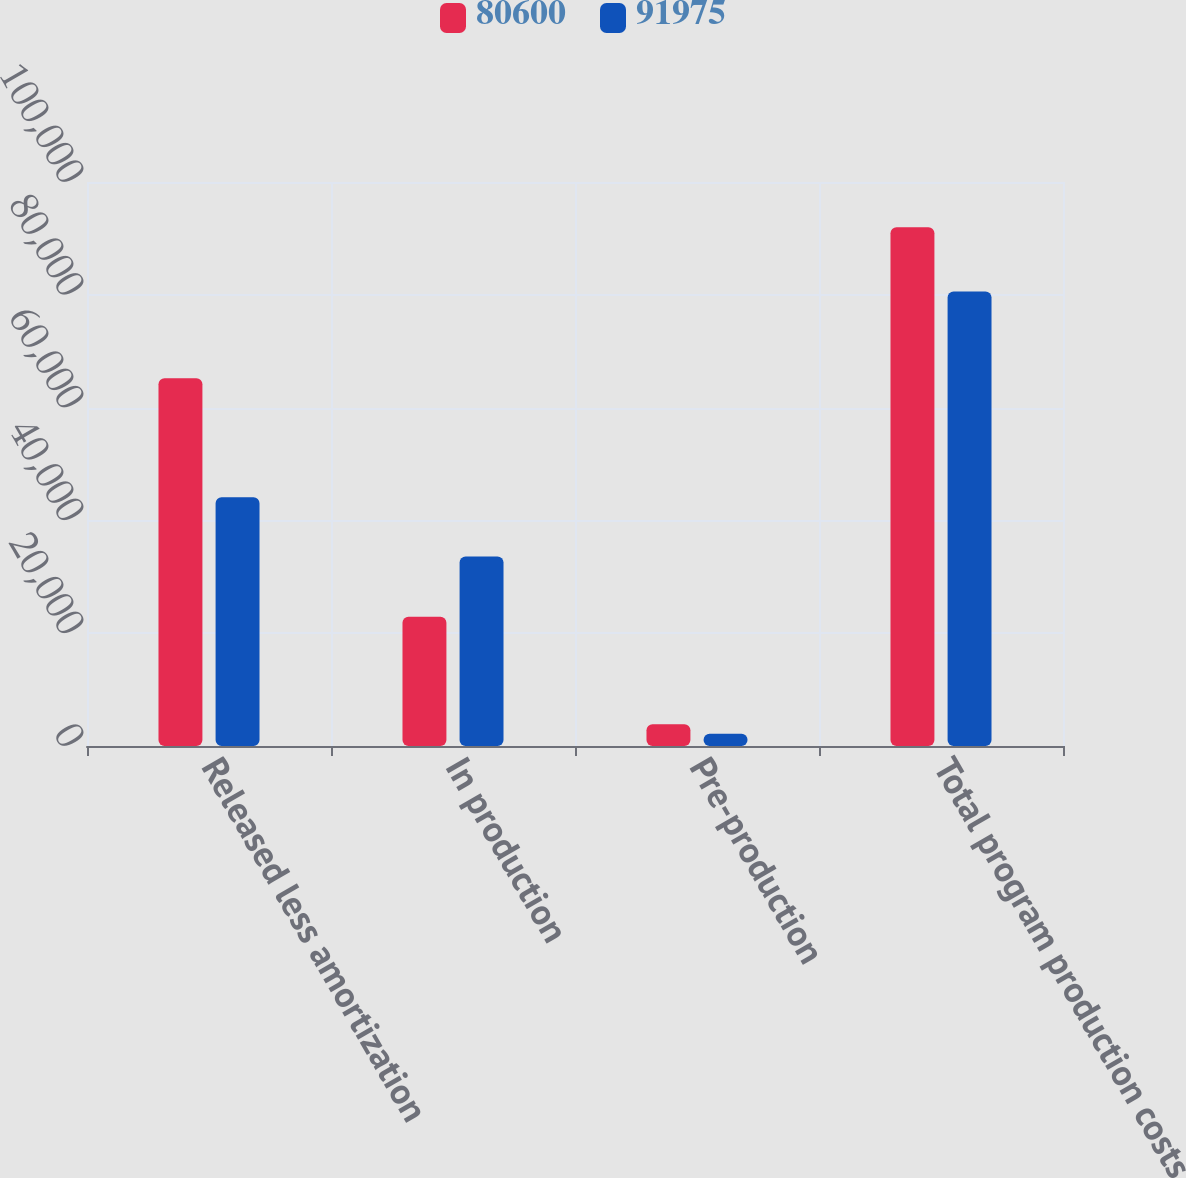<chart> <loc_0><loc_0><loc_500><loc_500><stacked_bar_chart><ecel><fcel>Released less amortization<fcel>In production<fcel>Pre-production<fcel>Total program production costs<nl><fcel>80600<fcel>65201<fcel>22909<fcel>3865<fcel>91975<nl><fcel>91975<fcel>44091<fcel>33583<fcel>2161<fcel>80600<nl></chart> 